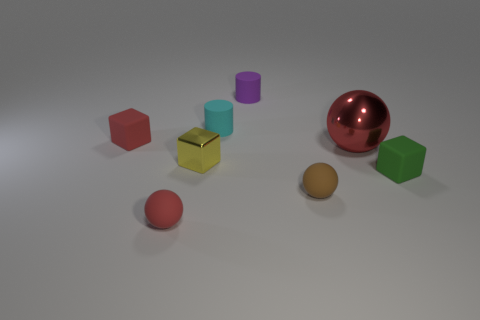What size is the cyan object that is behind the ball that is behind the tiny yellow cube?
Provide a succinct answer. Small. Are there an equal number of large shiny balls that are on the right side of the green object and cubes behind the purple matte cylinder?
Keep it short and to the point. Yes. Is there a tiny red matte thing that is behind the metallic object in front of the red shiny object?
Your answer should be very brief. Yes. What shape is the purple thing that is made of the same material as the small green cube?
Ensure brevity in your answer.  Cylinder. Are there any other things that have the same color as the big metal sphere?
Your answer should be very brief. Yes. What material is the red object on the left side of the small red matte thing that is right of the red block made of?
Provide a succinct answer. Rubber. Is there another object that has the same shape as the purple object?
Give a very brief answer. Yes. What number of other objects are there of the same shape as the purple thing?
Your answer should be compact. 1. There is a matte thing that is both on the left side of the brown object and right of the cyan cylinder; what shape is it?
Make the answer very short. Cylinder. What is the size of the red object right of the small yellow thing?
Offer a very short reply. Large. 